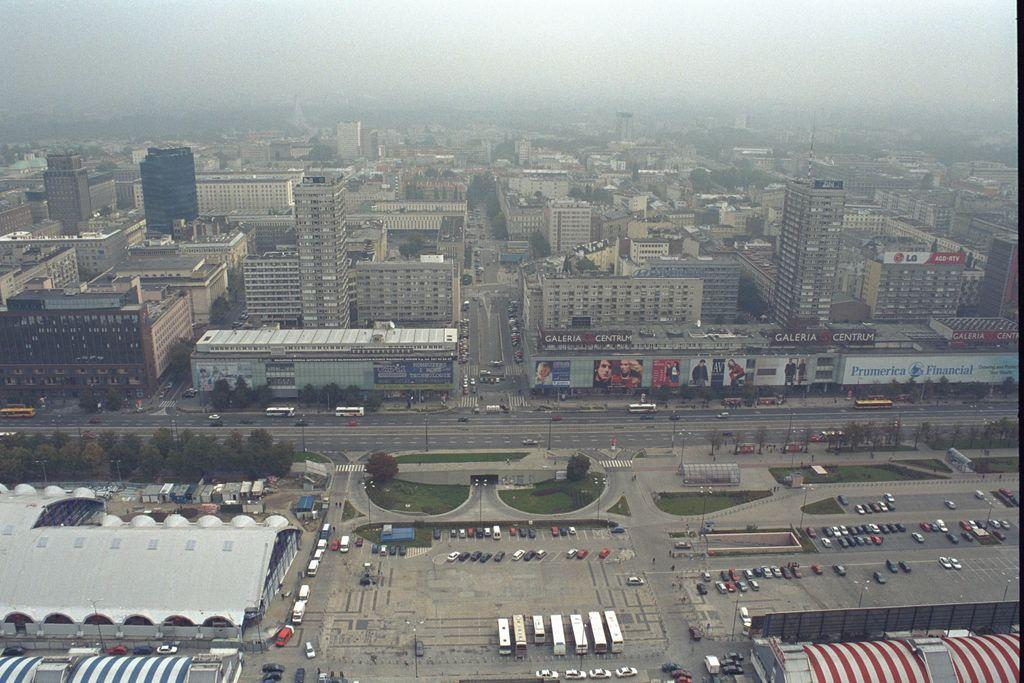What type of view is shown in the image? The image is an aerial view. What can be seen in the image from this perspective? There are many buildings, trees, vehicles, and roads visible in the image. How can you tell that there are roads in the image? The roads can be identified by their linear shape and the vehicles traveling on them. What is visible at the top of the image? The sky is visible at the top of the image. What type of cable can be seen connecting the buildings in the image? There is no cable connecting the buildings visible in the image. How does friction affect the movement of vehicles on the roads in the image? The image does not provide information about the movement of vehicles or the presence of friction, so it cannot be determined from the image. 